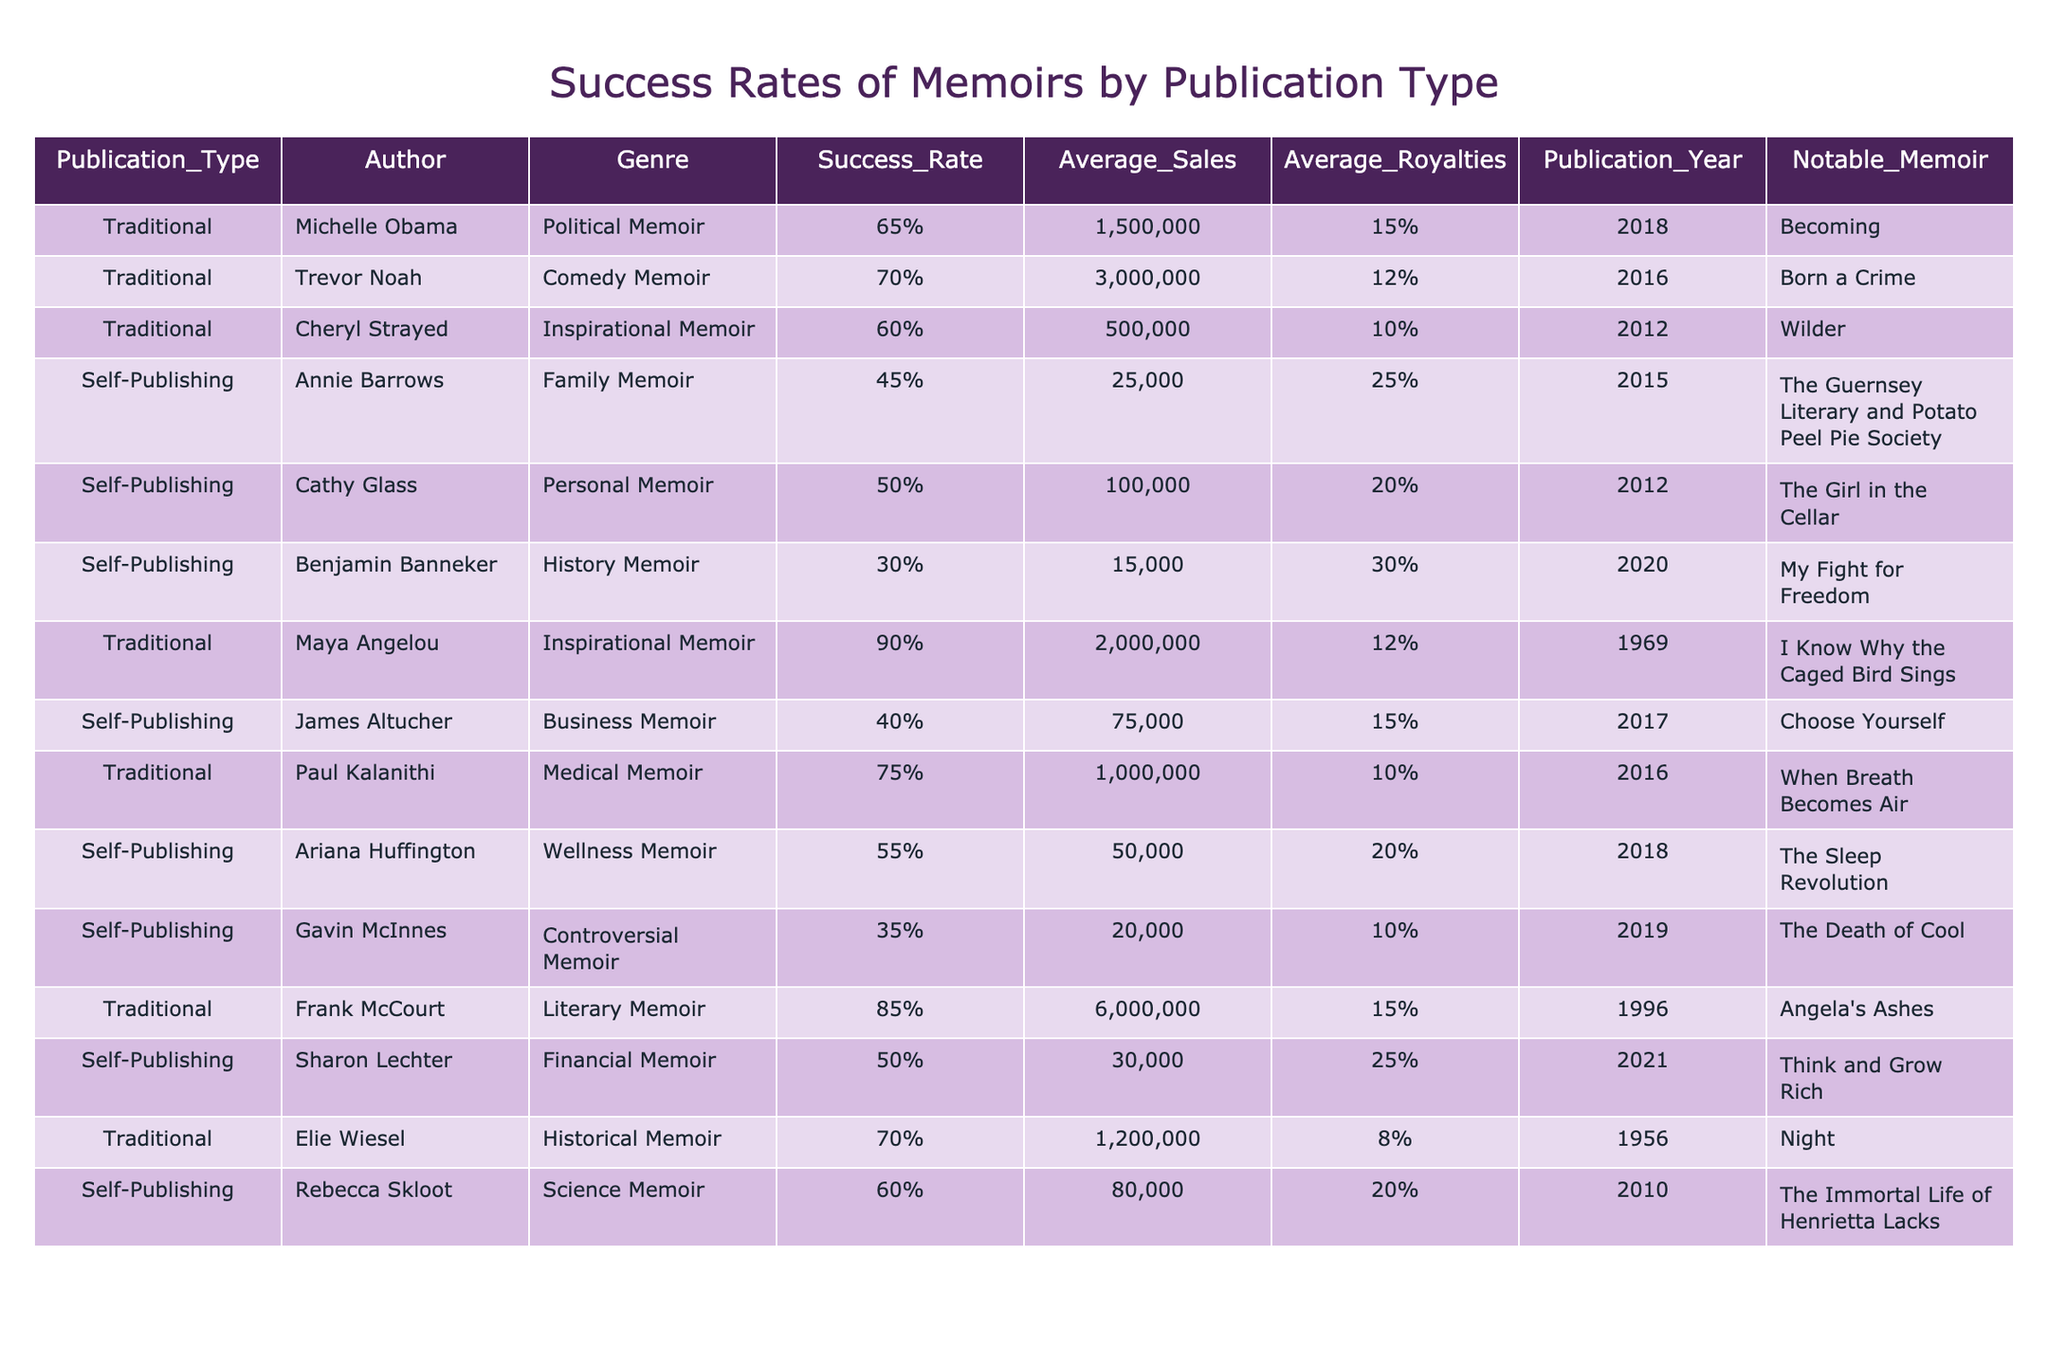What is the success rate of Trevor Noah's memoir? According to the table, Trevor Noah's memoir has a success rate of 70%.
Answer: 70% Which author has the highest success rate for a traditional memoir? The table indicates that Maya Angelou has the highest success rate among traditional memoirs, which is 90%.
Answer: 90% What is the average sales figure for self-published memoirs? To find the average sales for self-published memoirs, sum up the sales of Annie Barrows (25,000), Cathy Glass (100,000), Benjamin Banneker (15,000), James Altucher (75,000), Ariana Huffington (50,000), Gavin McInnes (20,000), and Sharon Lechter (30,000), giving a total of 315,000. There are 7 entries, so the average is 315,000 / 7 = 45,000.
Answer: 45,000 Is it true that all traditional memoirs listed have a success rate above 60%? Reviewing the success rates, Michelle Obama (65%), Trevor Noah (70%), Cheryl Strayed (60%), Maya Angelou (90%), Paul Kalanithi (75%), Frank McCourt (85%), and Elie Wiesel (70%) all exceed 60%. Thus, the statement is true.
Answer: True What is the total average royalties percentage for all success memoirs in the table? For this calculation, we gather the average royalties from traditional memoirs: 15%, 12%, 10%, 12%, 10%, 15%, 8% (total = 92%). For self-publishing: 25%, 20%, 30%, 15%, 20%, 10%, 25% (total = 155%). Adding these gives 92 + 155 = 247%. There are 14 memoirs in total, so the average is 247% / 14 = 17.64%.
Answer: 17.64% Which publication type has a memoir with the highest average sales figure? From the table, traditional memoirs generally have higher sales figures than self-publishing. Frank McCourt's literary memoir has the highest sales at 6,000,000, which is far above any self-published memoir.
Answer: Traditional How many self-published memoirs have a success rate of 50% or higher? The self-published memoirs listed show Annie Barrows (45%), Cathy Glass (50%), Benjamin Banneker (30%), James Altucher (40%), Ariana Huffington (55%), Gavin McInnes (35%), and Sharon Lechter (50%). The following authors: Cathy Glass, Ariana Huffington, and Sharon Lechter have success rates of 50% or higher (a total of 3).
Answer: 3 What is the median success rate of traditional memoirs? Arranging the success rates of traditional memoirs (90%, 70%, 75%, 65%, 85%, 60%, 70%) gives: 60%, 65%, 70%, 70%, 75%, 85%, 90%. The median is the fourth value, which is 70%.
Answer: 70% 